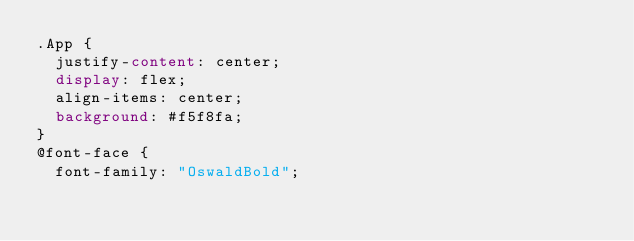<code> <loc_0><loc_0><loc_500><loc_500><_CSS_>.App {
  justify-content: center;
  display: flex;
  align-items: center;
  background: #f5f8fa;
}
@font-face {
  font-family: "OswaldBold";</code> 